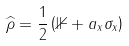<formula> <loc_0><loc_0><loc_500><loc_500>\widehat { \rho } = \frac { 1 } { 2 } \left ( \mathbb { 1 } + a _ { x } \sigma _ { x } \right )</formula> 